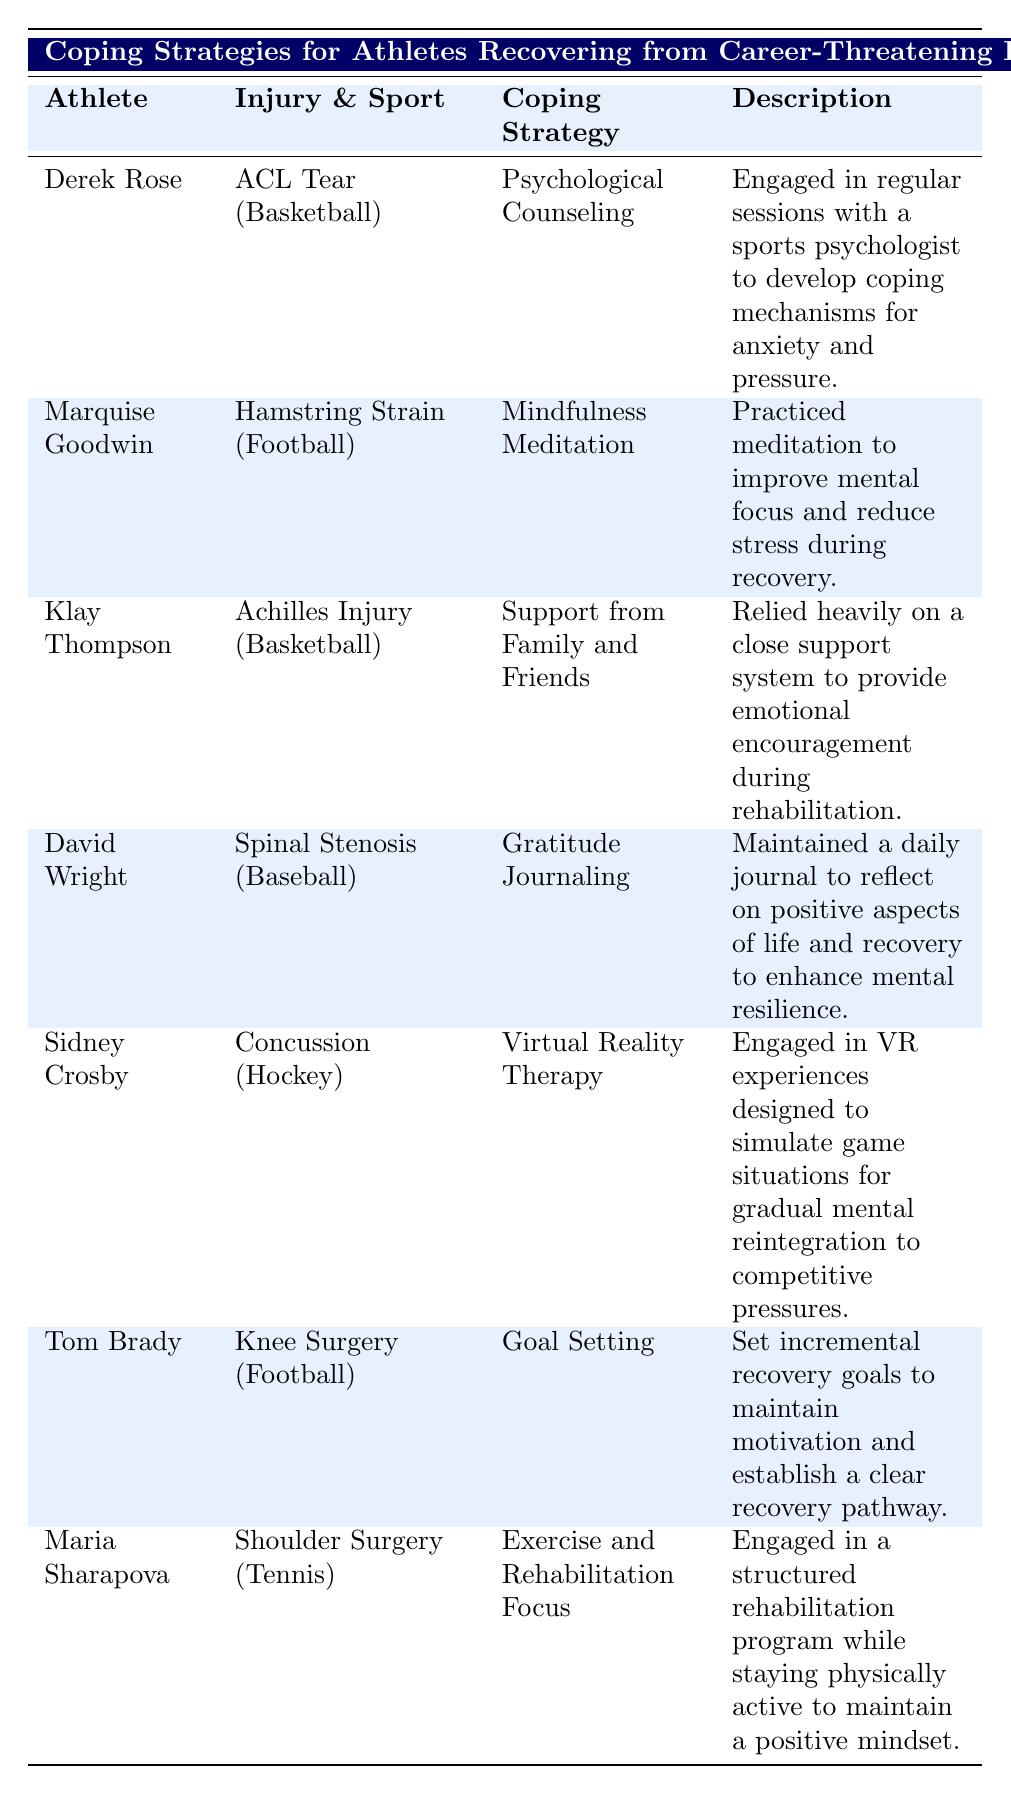What coping strategy did Derek Rose use during his recovery? The table lists Derek Rose's coping strategy as "Psychological Counseling." Therefore, the answer is found directly in the corresponding row of the table.
Answer: Psychological Counseling Which athlete relied on mindfulness meditation as a coping strategy? Marquise Goodwin is the athlete who employed "Mindfulness Meditation" to cope with his recovery, as indicated in the table.
Answer: Marquise Goodwin Did any athlete use goal setting as part of their coping strategy? By examining the table, we see that Tom Brady's coping strategy was "Goal Setting," confirming that this was indeed used as a coping method.
Answer: Yes How many different sports are represented in this table? To find the total number of sports represented, we can identify the unique sports listed: Basketball, Football, Hockey, and Tennis. That's a total of 4 unique sports.
Answer: 4 What is the coping strategy for Klay Thompson, and what does it involve? Klay Thompson's coping strategy is "Support from Family and Friends," and the description indicates it involved relying heavily on a close support system for emotional encouragement, which can be found directly in the table.
Answer: Support from Family and Friends What injury type is associated with Maria Sharapova? The table shows that Maria Sharapova's injury type is "Shoulder Surgery," which can be verified by looking at her row in the table.
Answer: Shoulder Surgery Did Sidney Crosby use a physical exercise program for his recovery? The row corresponding to Sidney Crosby lists "Virtual Reality Therapy" as his coping strategy, indicating that he did not use a physical exercise program, hence the answer is no.
Answer: No What common coping strategy was used by both athletes who played basketball? By examining the table, we observe that both Derek Rose and Klay Thompson's coping strategies are "Psychological Counseling" and "Support from Family and Friends," respectively, neither of which are the same, thus indicating no common strategy used by basketball athletes in this data.
Answer: None Which coping strategy focuses on maintaining a positive mindset through physical activity? The coping strategy associated with maintaining a positive mindset through physical activity is "Exercise and Rehabilitation Focus," as described for Maria Sharapova in the table.
Answer: Exercise and Rehabilitation Focus 